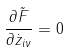<formula> <loc_0><loc_0><loc_500><loc_500>\frac { \partial \tilde { F } } { \partial \dot { z } _ { i \nu } } = 0</formula> 